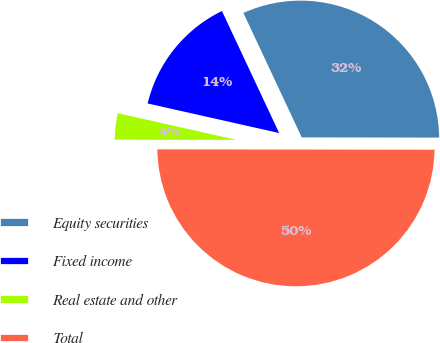Convert chart. <chart><loc_0><loc_0><loc_500><loc_500><pie_chart><fcel>Equity securities<fcel>Fixed income<fcel>Real estate and other<fcel>Total<nl><fcel>32.0%<fcel>14.5%<fcel>3.5%<fcel>50.0%<nl></chart> 